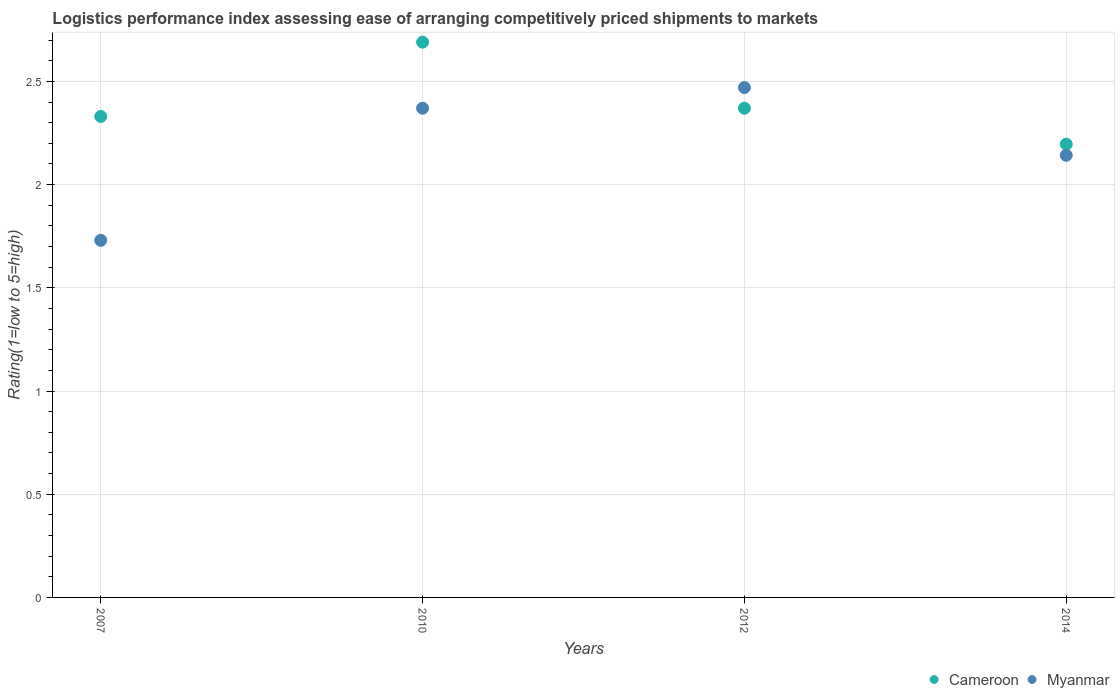What is the Logistic performance index in Myanmar in 2012?
Your response must be concise. 2.47. Across all years, what is the maximum Logistic performance index in Myanmar?
Ensure brevity in your answer.  2.47. Across all years, what is the minimum Logistic performance index in Cameroon?
Make the answer very short. 2.2. In which year was the Logistic performance index in Myanmar minimum?
Make the answer very short. 2007. What is the total Logistic performance index in Myanmar in the graph?
Your answer should be compact. 8.71. What is the difference between the Logistic performance index in Myanmar in 2010 and that in 2012?
Offer a terse response. -0.1. What is the difference between the Logistic performance index in Cameroon in 2014 and the Logistic performance index in Myanmar in 2012?
Provide a succinct answer. -0.27. What is the average Logistic performance index in Cameroon per year?
Your response must be concise. 2.4. In the year 2014, what is the difference between the Logistic performance index in Myanmar and Logistic performance index in Cameroon?
Provide a succinct answer. -0.05. What is the ratio of the Logistic performance index in Cameroon in 2012 to that in 2014?
Give a very brief answer. 1.08. Is the Logistic performance index in Cameroon in 2010 less than that in 2012?
Provide a succinct answer. No. What is the difference between the highest and the second highest Logistic performance index in Myanmar?
Offer a very short reply. 0.1. What is the difference between the highest and the lowest Logistic performance index in Cameroon?
Ensure brevity in your answer.  0.49. In how many years, is the Logistic performance index in Myanmar greater than the average Logistic performance index in Myanmar taken over all years?
Provide a succinct answer. 2. Is the sum of the Logistic performance index in Myanmar in 2007 and 2012 greater than the maximum Logistic performance index in Cameroon across all years?
Provide a succinct answer. Yes. Does the Logistic performance index in Myanmar monotonically increase over the years?
Provide a succinct answer. No. Is the Logistic performance index in Cameroon strictly greater than the Logistic performance index in Myanmar over the years?
Ensure brevity in your answer.  No. Is the Logistic performance index in Myanmar strictly less than the Logistic performance index in Cameroon over the years?
Give a very brief answer. No. How many dotlines are there?
Your answer should be very brief. 2. How many years are there in the graph?
Provide a short and direct response. 4. Does the graph contain any zero values?
Make the answer very short. No. Where does the legend appear in the graph?
Your answer should be compact. Bottom right. How many legend labels are there?
Keep it short and to the point. 2. How are the legend labels stacked?
Make the answer very short. Horizontal. What is the title of the graph?
Give a very brief answer. Logistics performance index assessing ease of arranging competitively priced shipments to markets. Does "Paraguay" appear as one of the legend labels in the graph?
Your answer should be compact. No. What is the label or title of the Y-axis?
Provide a succinct answer. Rating(1=low to 5=high). What is the Rating(1=low to 5=high) of Cameroon in 2007?
Your response must be concise. 2.33. What is the Rating(1=low to 5=high) of Myanmar in 2007?
Provide a short and direct response. 1.73. What is the Rating(1=low to 5=high) of Cameroon in 2010?
Keep it short and to the point. 2.69. What is the Rating(1=low to 5=high) in Myanmar in 2010?
Ensure brevity in your answer.  2.37. What is the Rating(1=low to 5=high) of Cameroon in 2012?
Make the answer very short. 2.37. What is the Rating(1=low to 5=high) of Myanmar in 2012?
Offer a very short reply. 2.47. What is the Rating(1=low to 5=high) of Cameroon in 2014?
Provide a short and direct response. 2.2. What is the Rating(1=low to 5=high) of Myanmar in 2014?
Make the answer very short. 2.14. Across all years, what is the maximum Rating(1=low to 5=high) in Cameroon?
Offer a very short reply. 2.69. Across all years, what is the maximum Rating(1=low to 5=high) in Myanmar?
Ensure brevity in your answer.  2.47. Across all years, what is the minimum Rating(1=low to 5=high) of Cameroon?
Ensure brevity in your answer.  2.2. Across all years, what is the minimum Rating(1=low to 5=high) in Myanmar?
Offer a terse response. 1.73. What is the total Rating(1=low to 5=high) of Cameroon in the graph?
Your answer should be very brief. 9.59. What is the total Rating(1=low to 5=high) in Myanmar in the graph?
Your answer should be very brief. 8.71. What is the difference between the Rating(1=low to 5=high) in Cameroon in 2007 and that in 2010?
Make the answer very short. -0.36. What is the difference between the Rating(1=low to 5=high) of Myanmar in 2007 and that in 2010?
Your answer should be compact. -0.64. What is the difference between the Rating(1=low to 5=high) of Cameroon in 2007 and that in 2012?
Offer a very short reply. -0.04. What is the difference between the Rating(1=low to 5=high) of Myanmar in 2007 and that in 2012?
Offer a terse response. -0.74. What is the difference between the Rating(1=low to 5=high) of Cameroon in 2007 and that in 2014?
Ensure brevity in your answer.  0.13. What is the difference between the Rating(1=low to 5=high) in Myanmar in 2007 and that in 2014?
Offer a very short reply. -0.41. What is the difference between the Rating(1=low to 5=high) in Cameroon in 2010 and that in 2012?
Ensure brevity in your answer.  0.32. What is the difference between the Rating(1=low to 5=high) in Cameroon in 2010 and that in 2014?
Ensure brevity in your answer.  0.49. What is the difference between the Rating(1=low to 5=high) in Myanmar in 2010 and that in 2014?
Your answer should be compact. 0.23. What is the difference between the Rating(1=low to 5=high) in Cameroon in 2012 and that in 2014?
Offer a very short reply. 0.17. What is the difference between the Rating(1=low to 5=high) of Myanmar in 2012 and that in 2014?
Offer a terse response. 0.33. What is the difference between the Rating(1=low to 5=high) in Cameroon in 2007 and the Rating(1=low to 5=high) in Myanmar in 2010?
Make the answer very short. -0.04. What is the difference between the Rating(1=low to 5=high) of Cameroon in 2007 and the Rating(1=low to 5=high) of Myanmar in 2012?
Your answer should be very brief. -0.14. What is the difference between the Rating(1=low to 5=high) in Cameroon in 2007 and the Rating(1=low to 5=high) in Myanmar in 2014?
Provide a short and direct response. 0.19. What is the difference between the Rating(1=low to 5=high) in Cameroon in 2010 and the Rating(1=low to 5=high) in Myanmar in 2012?
Keep it short and to the point. 0.22. What is the difference between the Rating(1=low to 5=high) of Cameroon in 2010 and the Rating(1=low to 5=high) of Myanmar in 2014?
Your answer should be compact. 0.55. What is the difference between the Rating(1=low to 5=high) in Cameroon in 2012 and the Rating(1=low to 5=high) in Myanmar in 2014?
Provide a succinct answer. 0.23. What is the average Rating(1=low to 5=high) in Cameroon per year?
Offer a very short reply. 2.4. What is the average Rating(1=low to 5=high) of Myanmar per year?
Make the answer very short. 2.18. In the year 2010, what is the difference between the Rating(1=low to 5=high) in Cameroon and Rating(1=low to 5=high) in Myanmar?
Your answer should be very brief. 0.32. In the year 2014, what is the difference between the Rating(1=low to 5=high) of Cameroon and Rating(1=low to 5=high) of Myanmar?
Your response must be concise. 0.05. What is the ratio of the Rating(1=low to 5=high) in Cameroon in 2007 to that in 2010?
Provide a succinct answer. 0.87. What is the ratio of the Rating(1=low to 5=high) in Myanmar in 2007 to that in 2010?
Keep it short and to the point. 0.73. What is the ratio of the Rating(1=low to 5=high) in Cameroon in 2007 to that in 2012?
Make the answer very short. 0.98. What is the ratio of the Rating(1=low to 5=high) of Myanmar in 2007 to that in 2012?
Offer a very short reply. 0.7. What is the ratio of the Rating(1=low to 5=high) of Cameroon in 2007 to that in 2014?
Make the answer very short. 1.06. What is the ratio of the Rating(1=low to 5=high) of Myanmar in 2007 to that in 2014?
Provide a succinct answer. 0.81. What is the ratio of the Rating(1=low to 5=high) in Cameroon in 2010 to that in 2012?
Make the answer very short. 1.14. What is the ratio of the Rating(1=low to 5=high) in Myanmar in 2010 to that in 2012?
Your answer should be very brief. 0.96. What is the ratio of the Rating(1=low to 5=high) of Cameroon in 2010 to that in 2014?
Provide a short and direct response. 1.23. What is the ratio of the Rating(1=low to 5=high) in Myanmar in 2010 to that in 2014?
Give a very brief answer. 1.11. What is the ratio of the Rating(1=low to 5=high) of Cameroon in 2012 to that in 2014?
Your answer should be very brief. 1.08. What is the ratio of the Rating(1=low to 5=high) of Myanmar in 2012 to that in 2014?
Offer a very short reply. 1.15. What is the difference between the highest and the second highest Rating(1=low to 5=high) of Cameroon?
Ensure brevity in your answer.  0.32. What is the difference between the highest and the lowest Rating(1=low to 5=high) in Cameroon?
Make the answer very short. 0.49. What is the difference between the highest and the lowest Rating(1=low to 5=high) in Myanmar?
Give a very brief answer. 0.74. 